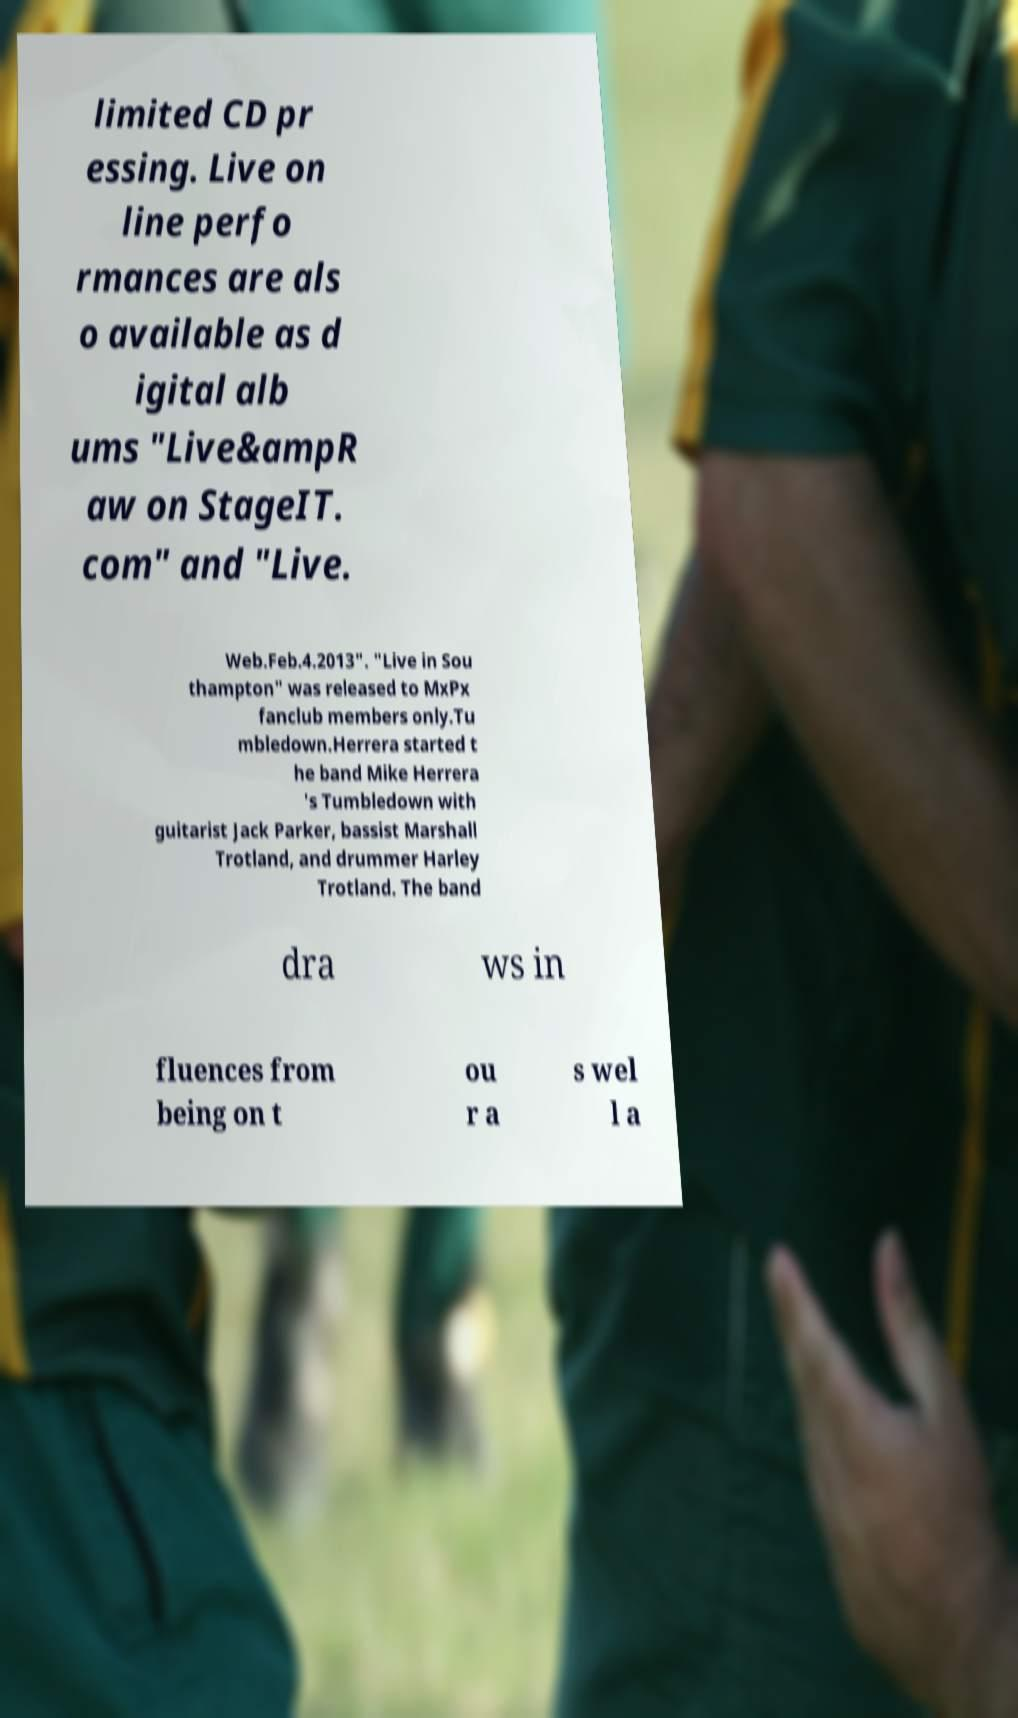Please identify and transcribe the text found in this image. limited CD pr essing. Live on line perfo rmances are als o available as d igital alb ums "Live&ampR aw on StageIT. com" and "Live. Web.Feb.4.2013". "Live in Sou thampton" was released to MxPx fanclub members only.Tu mbledown.Herrera started t he band Mike Herrera 's Tumbledown with guitarist Jack Parker, bassist Marshall Trotland, and drummer Harley Trotland. The band dra ws in fluences from being on t ou r a s wel l a 